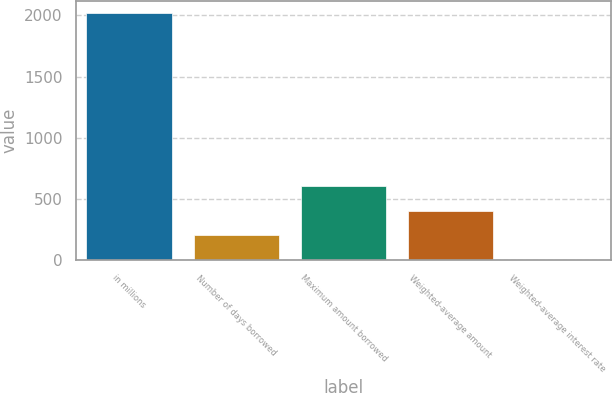Convert chart. <chart><loc_0><loc_0><loc_500><loc_500><bar_chart><fcel>in millions<fcel>Number of days borrowed<fcel>Maximum amount borrowed<fcel>Weighted-average amount<fcel>Weighted-average interest rate<nl><fcel>2017<fcel>204.3<fcel>607.12<fcel>405.71<fcel>2.89<nl></chart> 